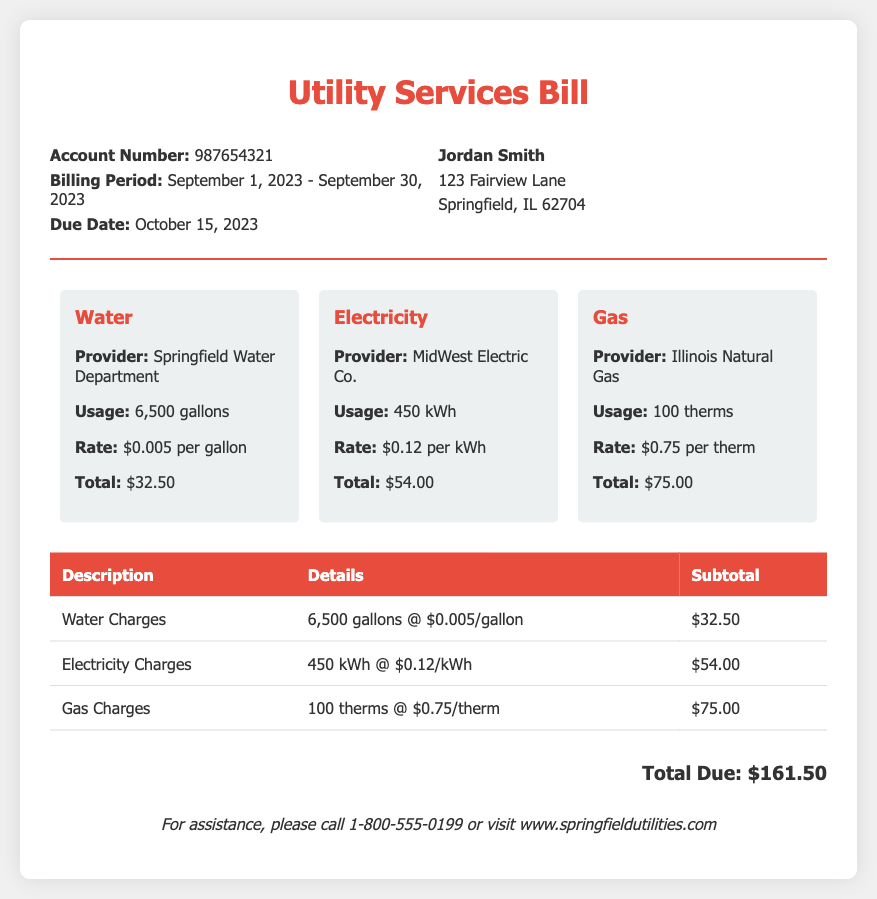What is the account number? The account number is provided in the bill header section, which is 987654321.
Answer: 987654321 What is the billing period? The billing period is stated clearly in the bill header, from September 1, 2023, to September 30, 2023.
Answer: September 1, 2023 - September 30, 2023 How much is the total due? The total due is clearly stated at the bottom of the bill, which is the sum of all utility charges.
Answer: $161.50 What is the usage for electricity? The electricity usage is indicated in the usage summary, which states 450 kWh.
Answer: 450 kWh Which provider supplies water? The provider for water is listed in the usage summary as Springfield Water Department.
Answer: Springfield Water Department How much is charged per gallon for water? The rate for water is mentioned in the usage summary, which is $0.005 per gallon.
Answer: $0.005 per gallon What are the gas charges? The gas charges details are found in the itemized section, stated as 100 therms at a rate of $0.75 per therm.
Answer: $75.00 What date is the payment due? The due date for the payment is indicated in the bill header, which is October 15, 2023.
Answer: October 15, 2023 What is the contact number for assistance? The contact number for assistance is listed at the bottom of the bill, which is 1-800-555-0199.
Answer: 1-800-555-0199 